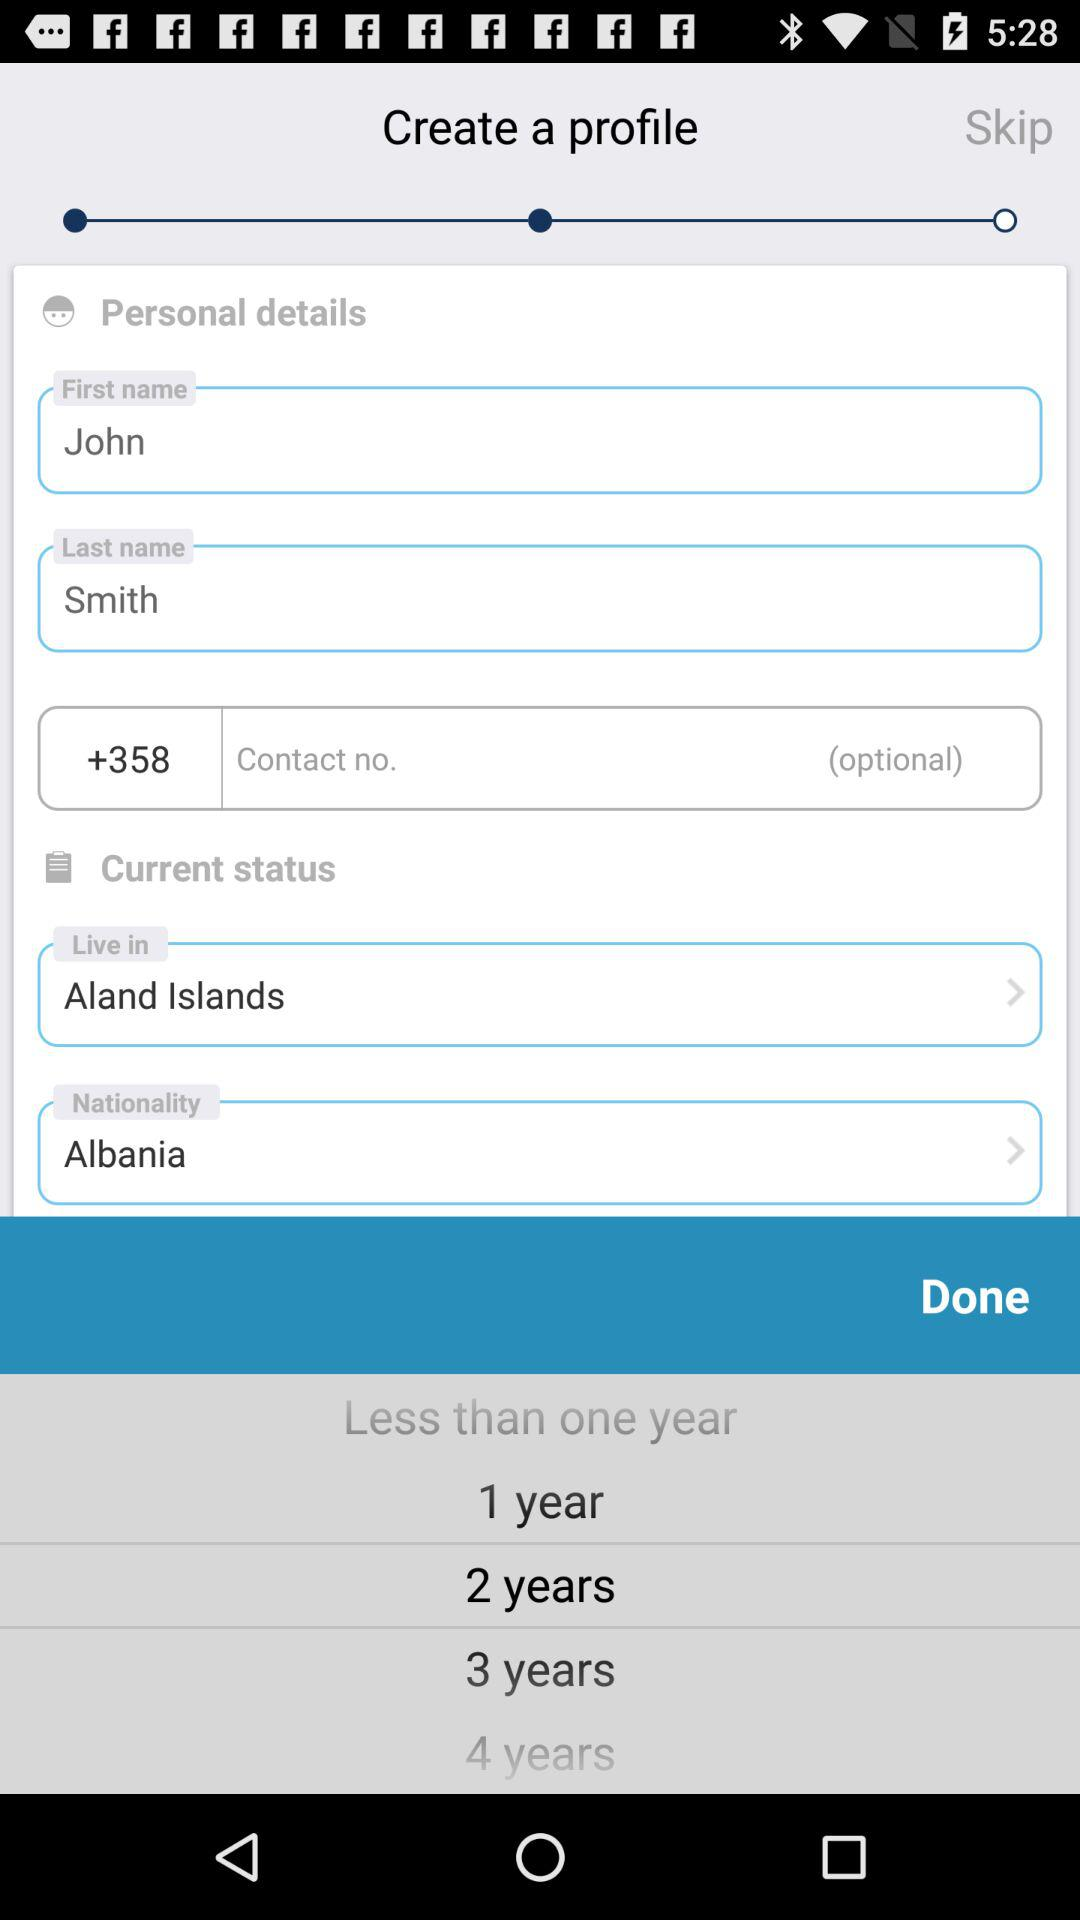What is the first name? The first name is John. 